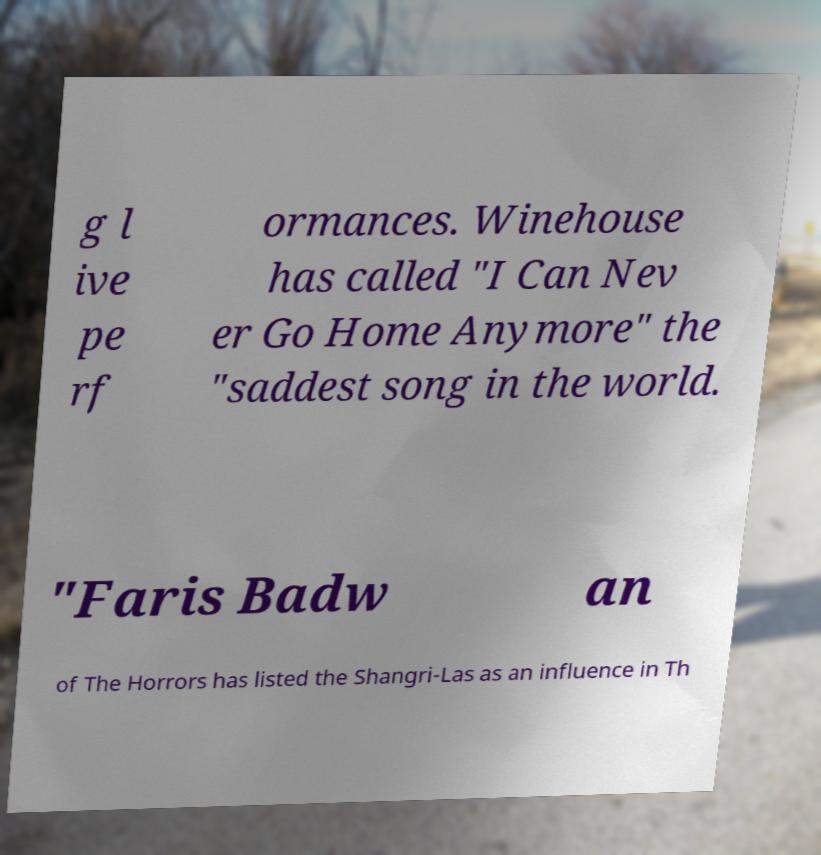Please identify and transcribe the text found in this image. g l ive pe rf ormances. Winehouse has called "I Can Nev er Go Home Anymore" the "saddest song in the world. "Faris Badw an of The Horrors has listed the Shangri-Las as an influence in Th 